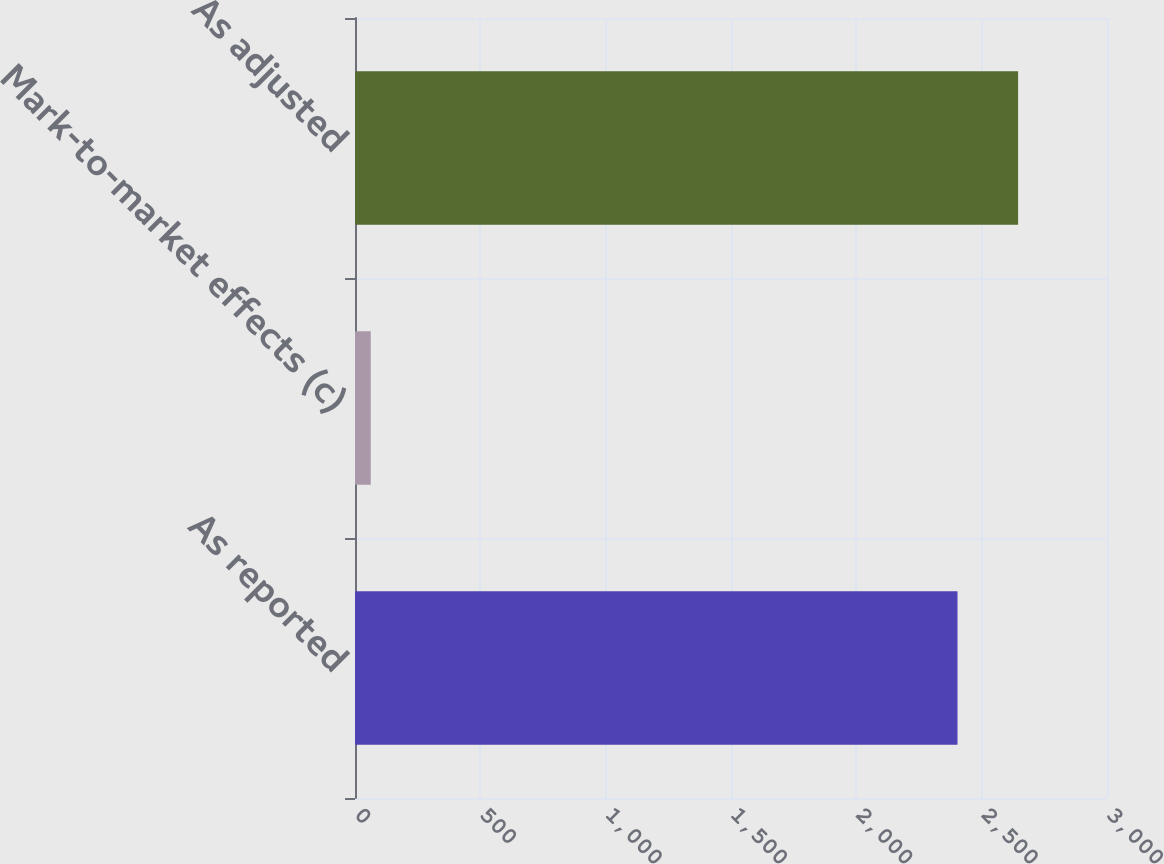Convert chart. <chart><loc_0><loc_0><loc_500><loc_500><bar_chart><fcel>As reported<fcel>Mark-to-market effects (c)<fcel>As adjusted<nl><fcel>2403.6<fcel>62.8<fcel>2645.31<nl></chart> 